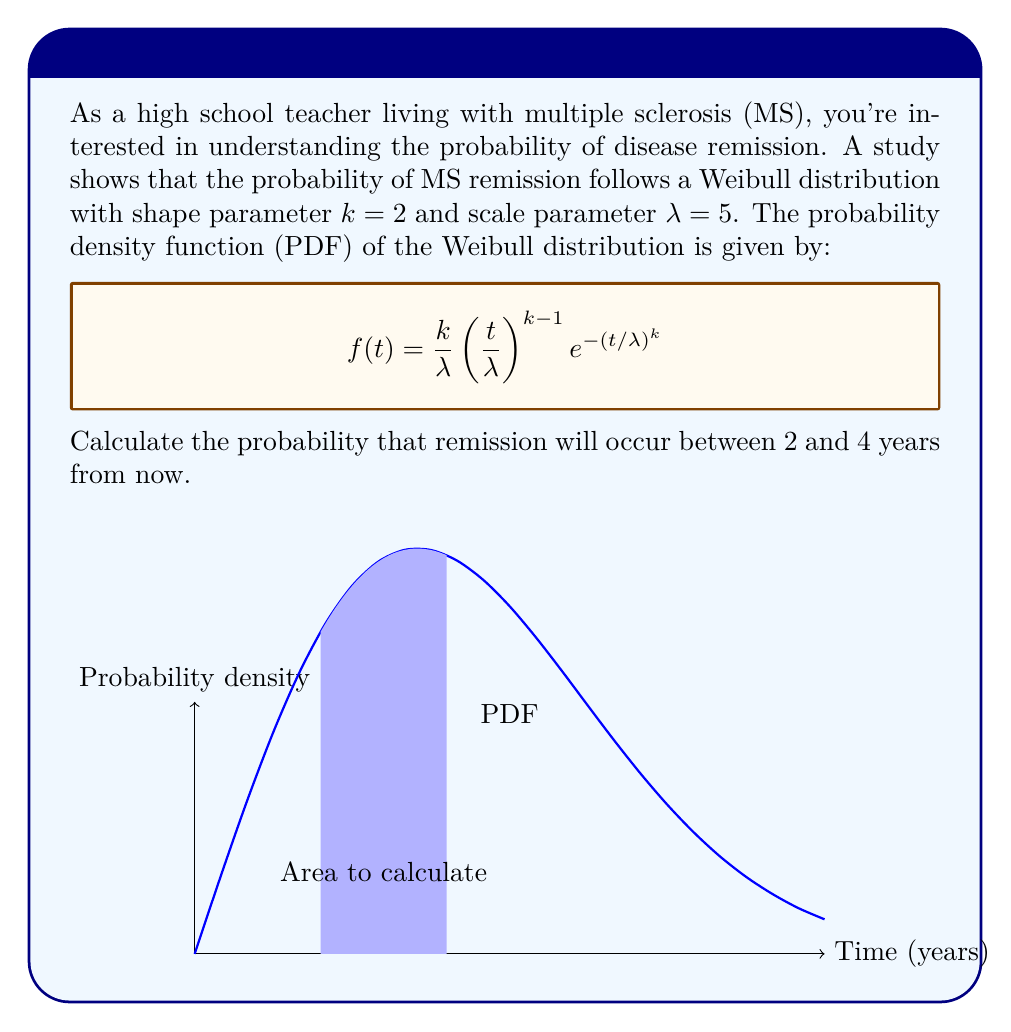Provide a solution to this math problem. Let's approach this step-by-step:

1) The probability of remission occurring between 2 and 4 years is the integral of the PDF from 2 to 4:

   $$P(2 \leq T \leq 4) = \int_2^4 f(t) dt$$

2) Substitute the given Weibull PDF with $k=2$ and $\lambda=5$:

   $$P(2 \leq T \leq 4) = \int_2^4 \frac{2}{25}t e^{-(t/5)^2} dt$$

3) This integral doesn't have a simple analytical solution, so we'll use the cumulative distribution function (CDF) of the Weibull distribution:

   $$F(t) = 1 - e^{-(t/\lambda)^k}$$

4) The probability can be calculated as the difference between the CDF at 4 and 2:

   $$P(2 \leq T \leq 4) = F(4) - F(2)$$

5) Calculate $F(4)$:
   $$F(4) = 1 - e^{-(4/5)^2} = 1 - e^{-0.64} \approx 0.4727$$

6) Calculate $F(2)$:
   $$F(2) = 1 - e^{-(2/5)^2} = 1 - e^{-0.16} \approx 0.1479$$

7) Calculate the difference:
   $$P(2 \leq T \leq 4) = F(4) - F(2) = 0.4727 - 0.1479 = 0.3248$$
Answer: $0.3248$ or $32.48\%$ 